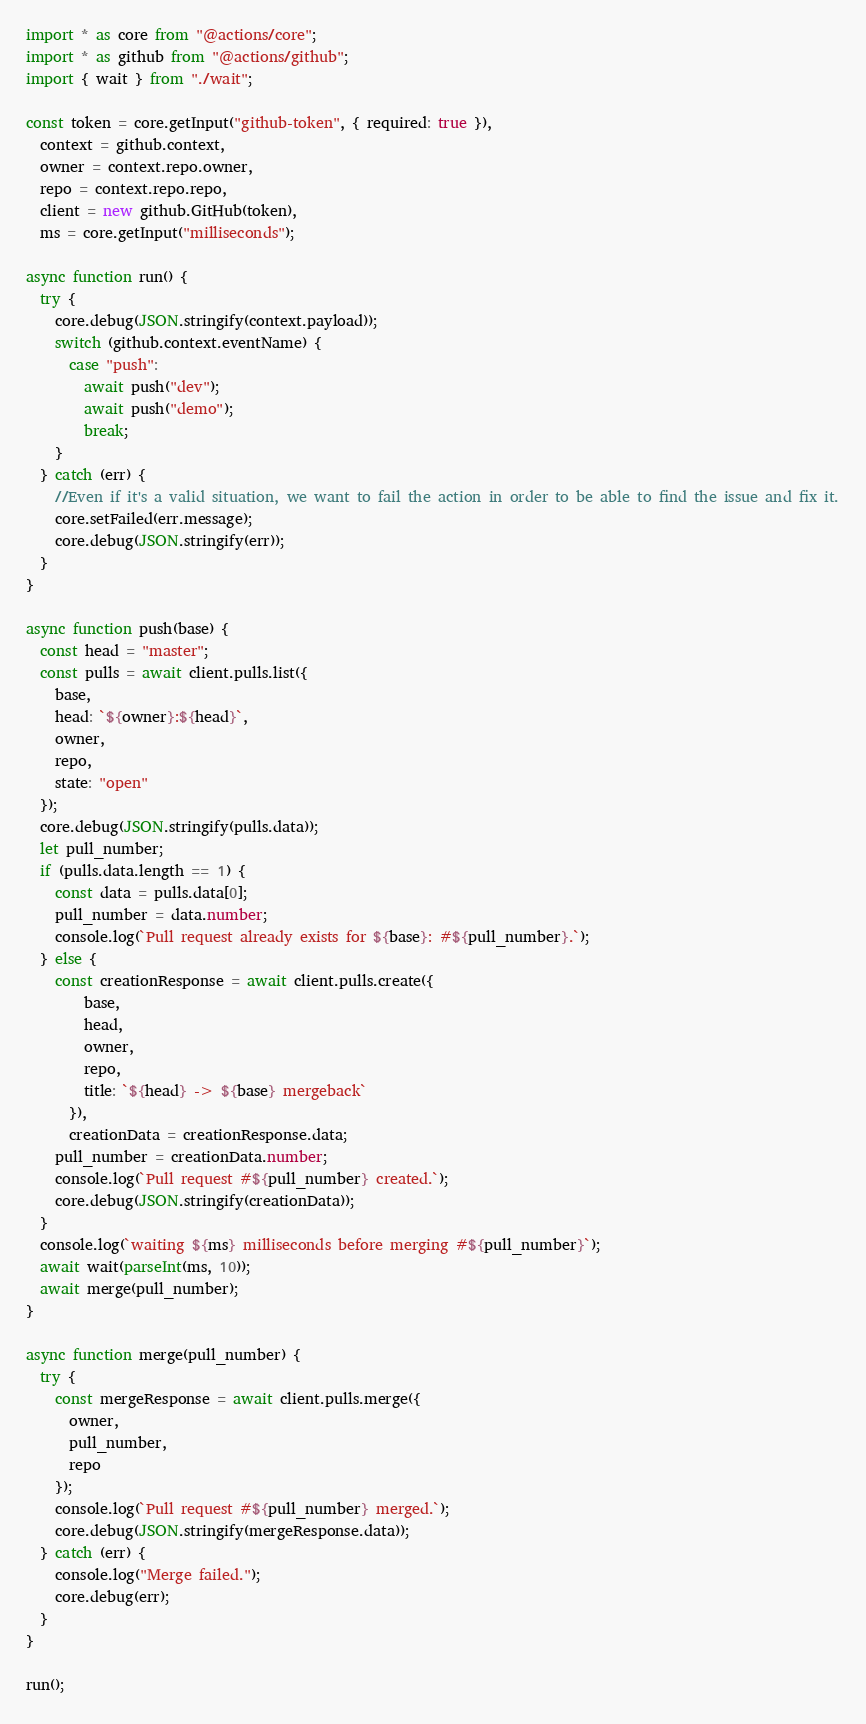<code> <loc_0><loc_0><loc_500><loc_500><_TypeScript_>import * as core from "@actions/core";
import * as github from "@actions/github";
import { wait } from "./wait";

const token = core.getInput("github-token", { required: true }),
  context = github.context,
  owner = context.repo.owner,
  repo = context.repo.repo,
  client = new github.GitHub(token),
  ms = core.getInput("milliseconds");

async function run() {
  try {
    core.debug(JSON.stringify(context.payload));
    switch (github.context.eventName) {
      case "push":
        await push("dev");
        await push("demo");
        break;
    }
  } catch (err) {
    //Even if it's a valid situation, we want to fail the action in order to be able to find the issue and fix it.
    core.setFailed(err.message);
    core.debug(JSON.stringify(err));
  }
}

async function push(base) {
  const head = "master";
  const pulls = await client.pulls.list({
    base,
    head: `${owner}:${head}`,
    owner,
    repo,
    state: "open"
  });
  core.debug(JSON.stringify(pulls.data));
  let pull_number;
  if (pulls.data.length == 1) {
    const data = pulls.data[0];
    pull_number = data.number;
    console.log(`Pull request already exists for ${base}: #${pull_number}.`);
  } else {
    const creationResponse = await client.pulls.create({
        base,
        head,
        owner,
        repo,
        title: `${head} -> ${base} mergeback`
      }),
      creationData = creationResponse.data;
    pull_number = creationData.number;
    console.log(`Pull request #${pull_number} created.`);
    core.debug(JSON.stringify(creationData));
  }
  console.log(`waiting ${ms} milliseconds before merging #${pull_number}`);
  await wait(parseInt(ms, 10));
  await merge(pull_number);
}

async function merge(pull_number) {
  try {
    const mergeResponse = await client.pulls.merge({
      owner,
      pull_number,
      repo
    });
    console.log(`Pull request #${pull_number} merged.`);
    core.debug(JSON.stringify(mergeResponse.data));
  } catch (err) {
    console.log("Merge failed.");
    core.debug(err);
  }
}

run();
</code> 